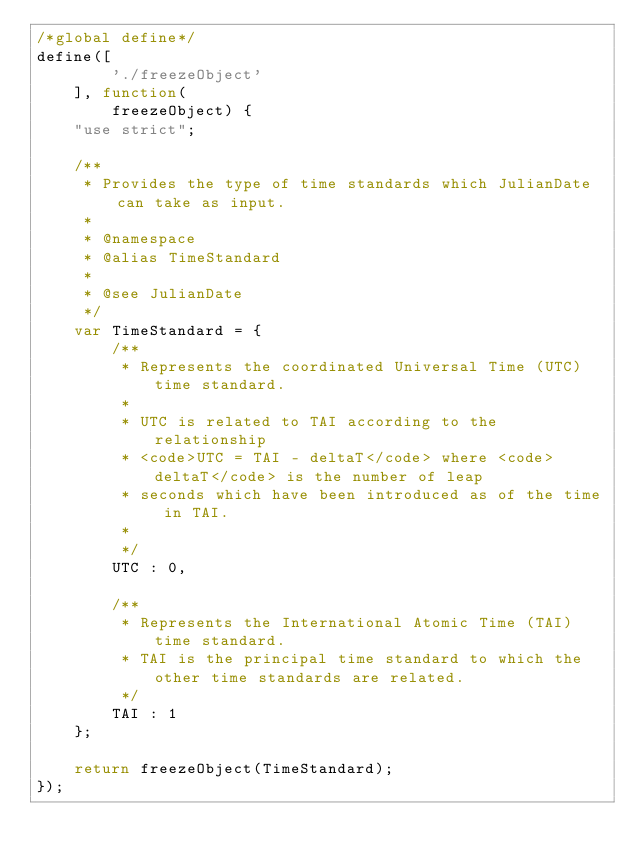Convert code to text. <code><loc_0><loc_0><loc_500><loc_500><_JavaScript_>/*global define*/
define([
        './freezeObject'
    ], function(
        freezeObject) {
    "use strict";

    /**
     * Provides the type of time standards which JulianDate can take as input.
     *
     * @namespace
     * @alias TimeStandard
     *
     * @see JulianDate
     */
    var TimeStandard = {
        /**
         * Represents the coordinated Universal Time (UTC) time standard.
         *
         * UTC is related to TAI according to the relationship
         * <code>UTC = TAI - deltaT</code> where <code>deltaT</code> is the number of leap
         * seconds which have been introduced as of the time in TAI.
         *
         */
        UTC : 0,

        /**
         * Represents the International Atomic Time (TAI) time standard.
         * TAI is the principal time standard to which the other time standards are related.
         */
        TAI : 1
    };

    return freezeObject(TimeStandard);
});</code> 